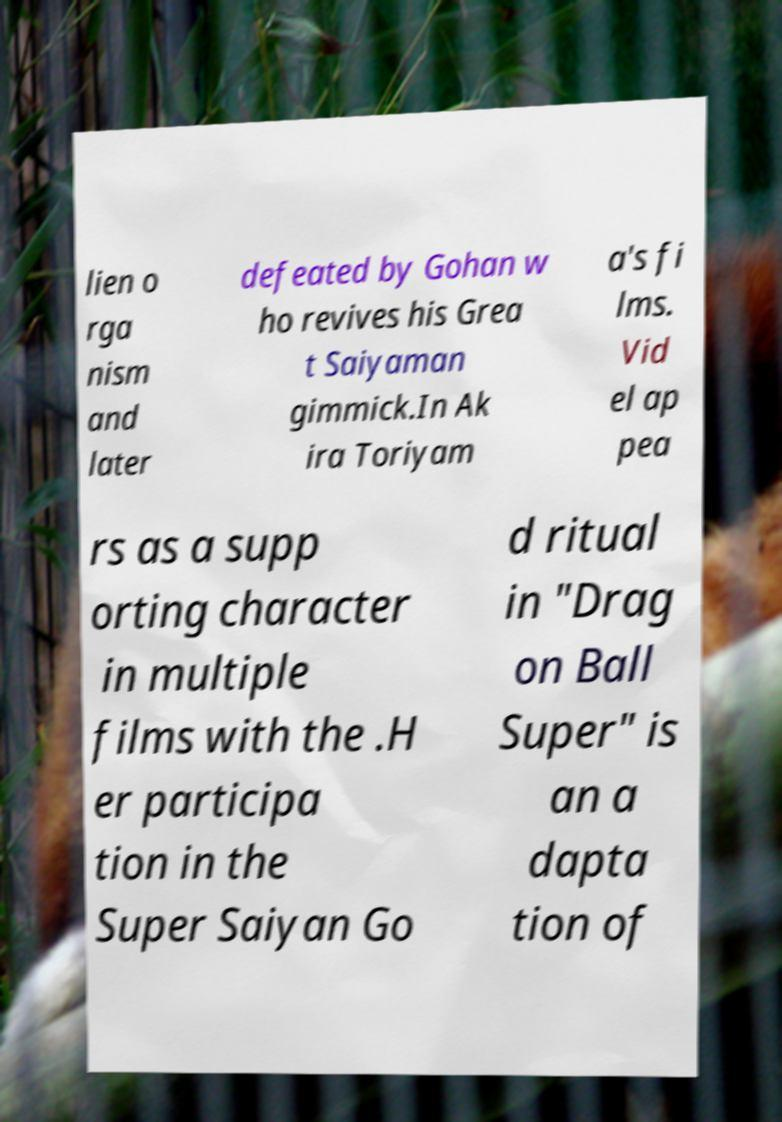Can you accurately transcribe the text from the provided image for me? lien o rga nism and later defeated by Gohan w ho revives his Grea t Saiyaman gimmick.In Ak ira Toriyam a's fi lms. Vid el ap pea rs as a supp orting character in multiple films with the .H er participa tion in the Super Saiyan Go d ritual in "Drag on Ball Super" is an a dapta tion of 